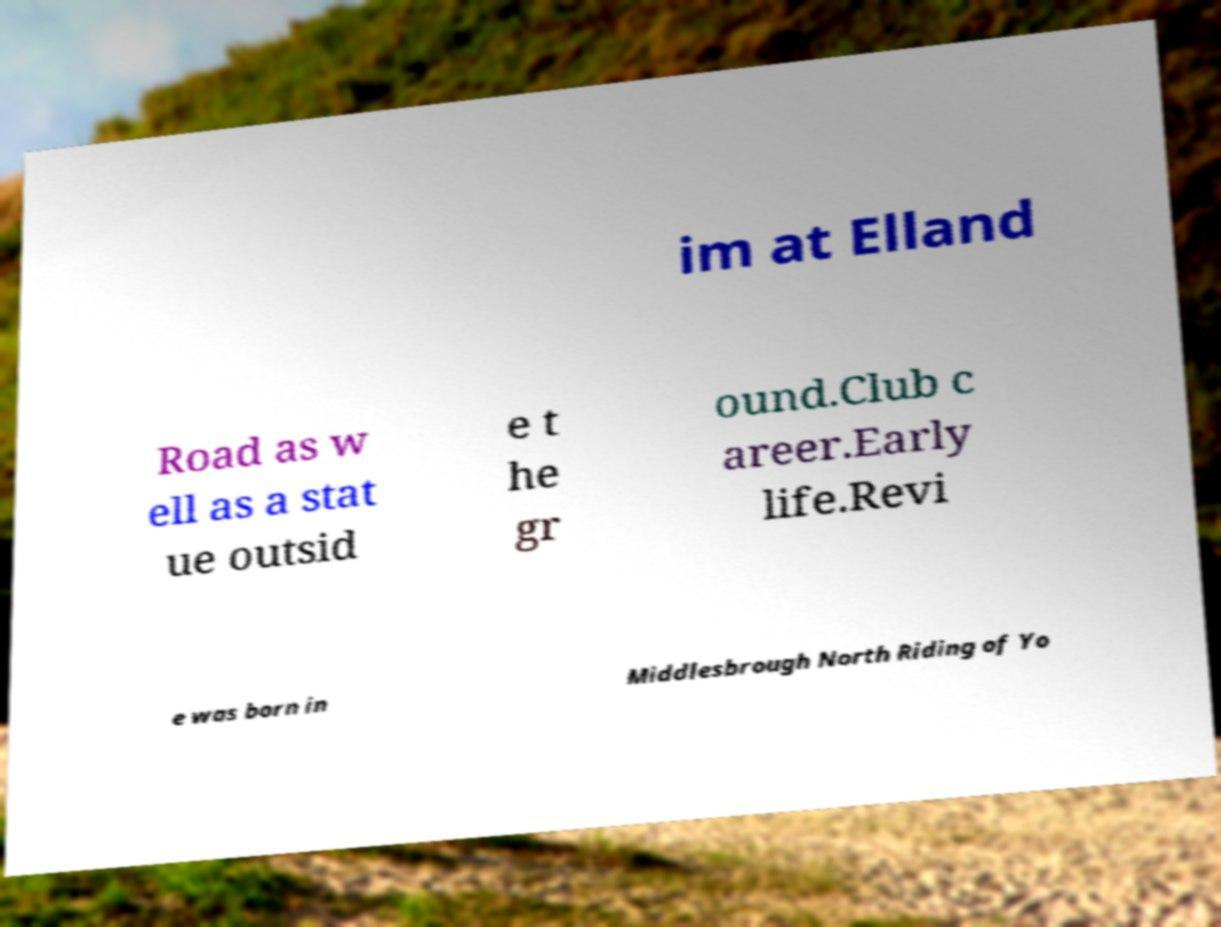I need the written content from this picture converted into text. Can you do that? im at Elland Road as w ell as a stat ue outsid e t he gr ound.Club c areer.Early life.Revi e was born in Middlesbrough North Riding of Yo 